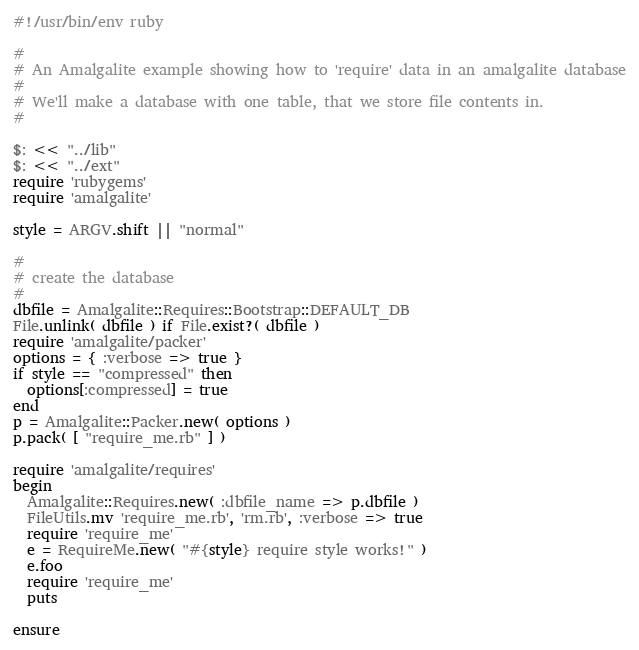<code> <loc_0><loc_0><loc_500><loc_500><_Ruby_>#!/usr/bin/env ruby

#
# An Amalgalite example showing how to 'require' data in an amalgalite database
#
# We'll make a database with one table, that we store file contents in.
#

$: << "../lib"
$: << "../ext"
require 'rubygems'
require 'amalgalite'

style = ARGV.shift || "normal"

#
# create the database 
#
dbfile = Amalgalite::Requires::Bootstrap::DEFAULT_DB
File.unlink( dbfile ) if File.exist?( dbfile )
require 'amalgalite/packer'
options = { :verbose => true }
if style == "compressed" then
  options[:compressed] = true
end
p = Amalgalite::Packer.new( options )
p.pack( [ "require_me.rb" ] )

require 'amalgalite/requires'
begin 
  Amalgalite::Requires.new( :dbfile_name => p.dbfile )
  FileUtils.mv 'require_me.rb', 'rm.rb', :verbose => true
  require 'require_me'
  e = RequireMe.new( "#{style} require style works!" )
  e.foo
  require 'require_me'
  puts 

ensure</code> 